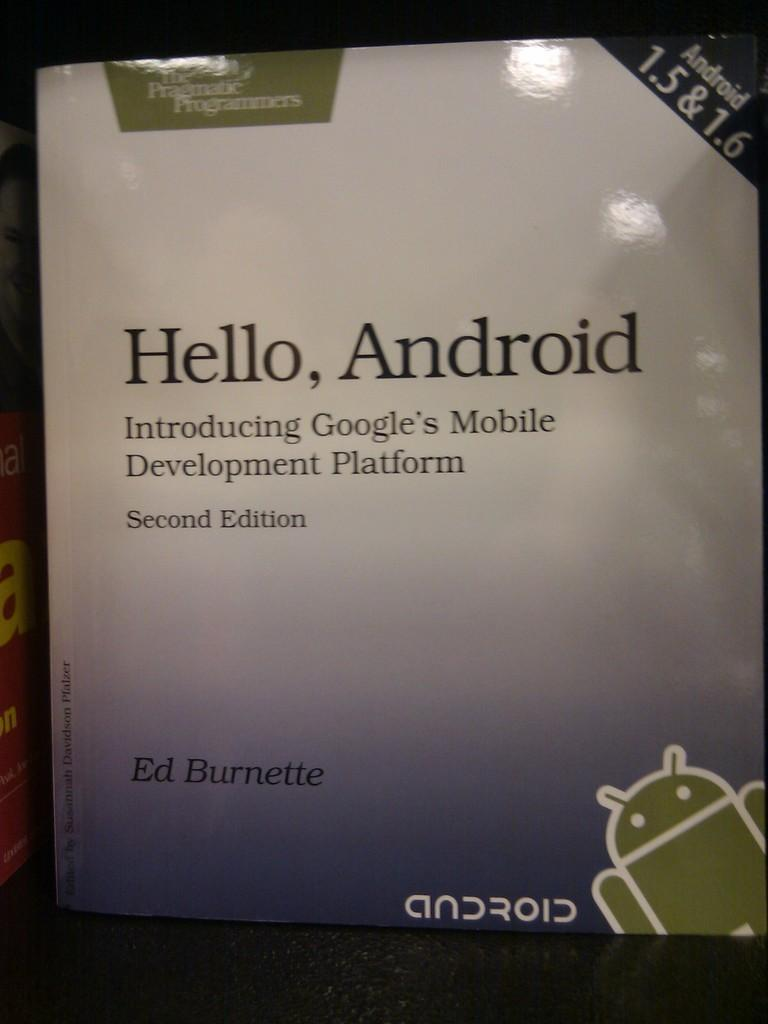Provide a one-sentence caption for the provided image. A book by Ed Burnette called Hello, Android. 